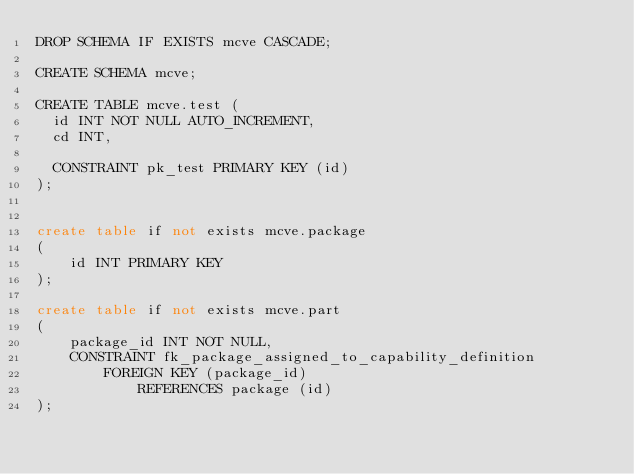Convert code to text. <code><loc_0><loc_0><loc_500><loc_500><_SQL_>DROP SCHEMA IF EXISTS mcve CASCADE;

CREATE SCHEMA mcve;

CREATE TABLE mcve.test (
  id INT NOT NULL AUTO_INCREMENT,
  cd INT,

  CONSTRAINT pk_test PRIMARY KEY (id)
);


create table if not exists mcve.package
(
    id INT PRIMARY KEY
);

create table if not exists mcve.part
(
    package_id INT NOT NULL,
    CONSTRAINT fk_package_assigned_to_capability_definition
        FOREIGN KEY (package_id)
            REFERENCES package (id)
);
</code> 